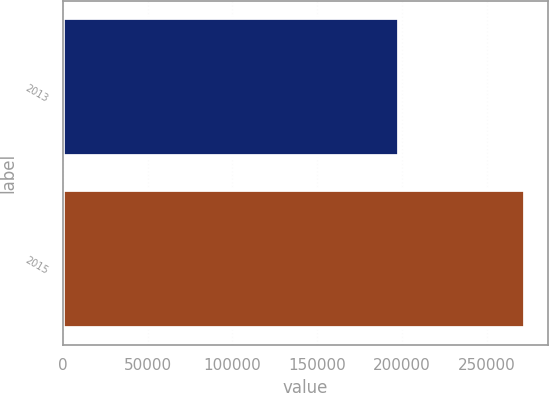<chart> <loc_0><loc_0><loc_500><loc_500><bar_chart><fcel>2013<fcel>2015<nl><fcel>197973<fcel>272329<nl></chart> 